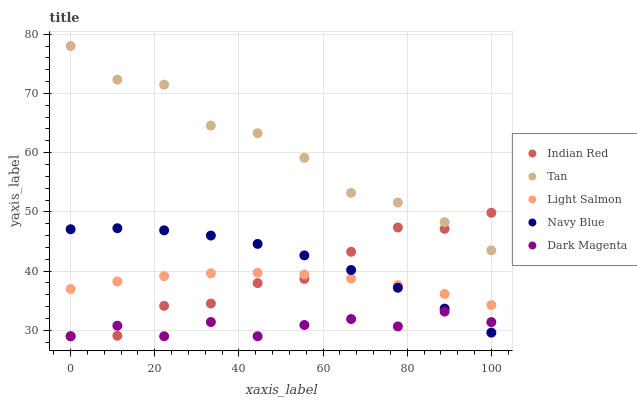Does Dark Magenta have the minimum area under the curve?
Answer yes or no. Yes. Does Tan have the maximum area under the curve?
Answer yes or no. Yes. Does Light Salmon have the minimum area under the curve?
Answer yes or no. No. Does Light Salmon have the maximum area under the curve?
Answer yes or no. No. Is Light Salmon the smoothest?
Answer yes or no. Yes. Is Tan the roughest?
Answer yes or no. Yes. Is Tan the smoothest?
Answer yes or no. No. Is Light Salmon the roughest?
Answer yes or no. No. Does Indian Red have the lowest value?
Answer yes or no. Yes. Does Light Salmon have the lowest value?
Answer yes or no. No. Does Tan have the highest value?
Answer yes or no. Yes. Does Light Salmon have the highest value?
Answer yes or no. No. Is Light Salmon less than Tan?
Answer yes or no. Yes. Is Tan greater than Light Salmon?
Answer yes or no. Yes. Does Indian Red intersect Dark Magenta?
Answer yes or no. Yes. Is Indian Red less than Dark Magenta?
Answer yes or no. No. Is Indian Red greater than Dark Magenta?
Answer yes or no. No. Does Light Salmon intersect Tan?
Answer yes or no. No. 